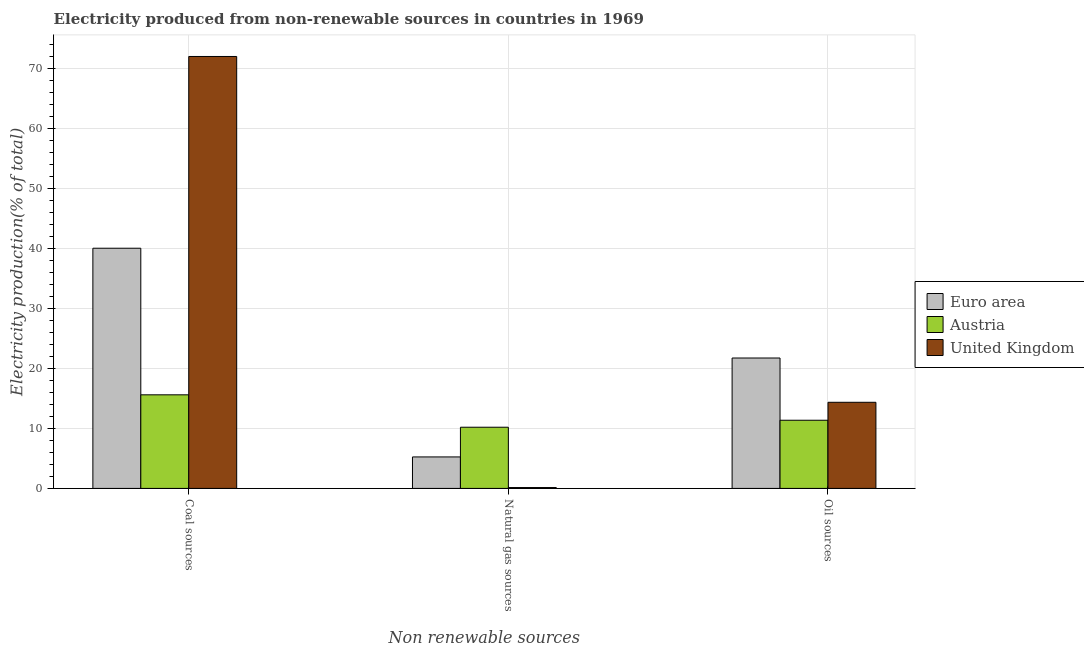How many different coloured bars are there?
Provide a succinct answer. 3. Are the number of bars on each tick of the X-axis equal?
Offer a terse response. Yes. What is the label of the 2nd group of bars from the left?
Ensure brevity in your answer.  Natural gas sources. What is the percentage of electricity produced by oil sources in Euro area?
Keep it short and to the point. 21.72. Across all countries, what is the maximum percentage of electricity produced by oil sources?
Provide a short and direct response. 21.72. Across all countries, what is the minimum percentage of electricity produced by oil sources?
Provide a succinct answer. 11.35. What is the total percentage of electricity produced by natural gas in the graph?
Your answer should be compact. 15.58. What is the difference between the percentage of electricity produced by natural gas in Euro area and that in United Kingdom?
Your response must be concise. 5.1. What is the difference between the percentage of electricity produced by natural gas in Euro area and the percentage of electricity produced by oil sources in United Kingdom?
Your answer should be compact. -9.1. What is the average percentage of electricity produced by coal per country?
Offer a very short reply. 42.5. What is the difference between the percentage of electricity produced by natural gas and percentage of electricity produced by oil sources in Austria?
Your answer should be compact. -1.16. What is the ratio of the percentage of electricity produced by oil sources in Euro area to that in Austria?
Keep it short and to the point. 1.91. Is the percentage of electricity produced by natural gas in United Kingdom less than that in Austria?
Make the answer very short. Yes. What is the difference between the highest and the second highest percentage of electricity produced by oil sources?
Your answer should be very brief. 7.37. What is the difference between the highest and the lowest percentage of electricity produced by natural gas?
Keep it short and to the point. 10.04. What does the 1st bar from the right in Natural gas sources represents?
Provide a succinct answer. United Kingdom. Is it the case that in every country, the sum of the percentage of electricity produced by coal and percentage of electricity produced by natural gas is greater than the percentage of electricity produced by oil sources?
Offer a terse response. Yes. How many bars are there?
Offer a terse response. 9. Are all the bars in the graph horizontal?
Give a very brief answer. No. What is the difference between two consecutive major ticks on the Y-axis?
Provide a short and direct response. 10. Are the values on the major ticks of Y-axis written in scientific E-notation?
Your response must be concise. No. Where does the legend appear in the graph?
Ensure brevity in your answer.  Center right. How many legend labels are there?
Provide a short and direct response. 3. How are the legend labels stacked?
Offer a very short reply. Vertical. What is the title of the graph?
Offer a very short reply. Electricity produced from non-renewable sources in countries in 1969. What is the label or title of the X-axis?
Provide a succinct answer. Non renewable sources. What is the Electricity production(% of total) of Euro area in Coal sources?
Keep it short and to the point. 39.99. What is the Electricity production(% of total) of Austria in Coal sources?
Ensure brevity in your answer.  15.59. What is the Electricity production(% of total) in United Kingdom in Coal sources?
Provide a short and direct response. 71.92. What is the Electricity production(% of total) in Euro area in Natural gas sources?
Provide a short and direct response. 5.24. What is the Electricity production(% of total) in Austria in Natural gas sources?
Provide a succinct answer. 10.19. What is the Electricity production(% of total) of United Kingdom in Natural gas sources?
Your answer should be very brief. 0.14. What is the Electricity production(% of total) in Euro area in Oil sources?
Your response must be concise. 21.72. What is the Electricity production(% of total) of Austria in Oil sources?
Provide a short and direct response. 11.35. What is the Electricity production(% of total) in United Kingdom in Oil sources?
Offer a very short reply. 14.34. Across all Non renewable sources, what is the maximum Electricity production(% of total) in Euro area?
Make the answer very short. 39.99. Across all Non renewable sources, what is the maximum Electricity production(% of total) in Austria?
Provide a succinct answer. 15.59. Across all Non renewable sources, what is the maximum Electricity production(% of total) in United Kingdom?
Provide a short and direct response. 71.92. Across all Non renewable sources, what is the minimum Electricity production(% of total) in Euro area?
Provide a short and direct response. 5.24. Across all Non renewable sources, what is the minimum Electricity production(% of total) of Austria?
Offer a terse response. 10.19. Across all Non renewable sources, what is the minimum Electricity production(% of total) of United Kingdom?
Your answer should be compact. 0.14. What is the total Electricity production(% of total) in Euro area in the graph?
Your answer should be very brief. 66.95. What is the total Electricity production(% of total) in Austria in the graph?
Your response must be concise. 37.13. What is the total Electricity production(% of total) in United Kingdom in the graph?
Your response must be concise. 86.41. What is the difference between the Electricity production(% of total) in Euro area in Coal sources and that in Natural gas sources?
Your answer should be very brief. 34.75. What is the difference between the Electricity production(% of total) in Austria in Coal sources and that in Natural gas sources?
Your answer should be very brief. 5.4. What is the difference between the Electricity production(% of total) in United Kingdom in Coal sources and that in Natural gas sources?
Your answer should be very brief. 71.78. What is the difference between the Electricity production(% of total) of Euro area in Coal sources and that in Oil sources?
Your answer should be very brief. 18.28. What is the difference between the Electricity production(% of total) of Austria in Coal sources and that in Oil sources?
Make the answer very short. 4.23. What is the difference between the Electricity production(% of total) in United Kingdom in Coal sources and that in Oil sources?
Provide a short and direct response. 57.58. What is the difference between the Electricity production(% of total) of Euro area in Natural gas sources and that in Oil sources?
Your answer should be very brief. -16.47. What is the difference between the Electricity production(% of total) in Austria in Natural gas sources and that in Oil sources?
Offer a terse response. -1.16. What is the difference between the Electricity production(% of total) in United Kingdom in Natural gas sources and that in Oil sources?
Your response must be concise. -14.2. What is the difference between the Electricity production(% of total) of Euro area in Coal sources and the Electricity production(% of total) of Austria in Natural gas sources?
Give a very brief answer. 29.81. What is the difference between the Electricity production(% of total) of Euro area in Coal sources and the Electricity production(% of total) of United Kingdom in Natural gas sources?
Offer a terse response. 39.85. What is the difference between the Electricity production(% of total) of Austria in Coal sources and the Electricity production(% of total) of United Kingdom in Natural gas sources?
Provide a short and direct response. 15.44. What is the difference between the Electricity production(% of total) of Euro area in Coal sources and the Electricity production(% of total) of Austria in Oil sources?
Make the answer very short. 28.64. What is the difference between the Electricity production(% of total) of Euro area in Coal sources and the Electricity production(% of total) of United Kingdom in Oil sources?
Keep it short and to the point. 25.65. What is the difference between the Electricity production(% of total) of Austria in Coal sources and the Electricity production(% of total) of United Kingdom in Oil sources?
Provide a short and direct response. 1.24. What is the difference between the Electricity production(% of total) of Euro area in Natural gas sources and the Electricity production(% of total) of Austria in Oil sources?
Provide a succinct answer. -6.11. What is the difference between the Electricity production(% of total) of Euro area in Natural gas sources and the Electricity production(% of total) of United Kingdom in Oil sources?
Give a very brief answer. -9.1. What is the difference between the Electricity production(% of total) in Austria in Natural gas sources and the Electricity production(% of total) in United Kingdom in Oil sources?
Offer a terse response. -4.15. What is the average Electricity production(% of total) in Euro area per Non renewable sources?
Provide a short and direct response. 22.32. What is the average Electricity production(% of total) of Austria per Non renewable sources?
Your response must be concise. 12.38. What is the average Electricity production(% of total) of United Kingdom per Non renewable sources?
Give a very brief answer. 28.8. What is the difference between the Electricity production(% of total) in Euro area and Electricity production(% of total) in Austria in Coal sources?
Offer a terse response. 24.41. What is the difference between the Electricity production(% of total) of Euro area and Electricity production(% of total) of United Kingdom in Coal sources?
Your answer should be very brief. -31.93. What is the difference between the Electricity production(% of total) of Austria and Electricity production(% of total) of United Kingdom in Coal sources?
Keep it short and to the point. -56.34. What is the difference between the Electricity production(% of total) of Euro area and Electricity production(% of total) of Austria in Natural gas sources?
Your response must be concise. -4.94. What is the difference between the Electricity production(% of total) in Euro area and Electricity production(% of total) in United Kingdom in Natural gas sources?
Ensure brevity in your answer.  5.1. What is the difference between the Electricity production(% of total) of Austria and Electricity production(% of total) of United Kingdom in Natural gas sources?
Keep it short and to the point. 10.04. What is the difference between the Electricity production(% of total) of Euro area and Electricity production(% of total) of Austria in Oil sources?
Provide a succinct answer. 10.36. What is the difference between the Electricity production(% of total) in Euro area and Electricity production(% of total) in United Kingdom in Oil sources?
Make the answer very short. 7.37. What is the difference between the Electricity production(% of total) of Austria and Electricity production(% of total) of United Kingdom in Oil sources?
Your response must be concise. -2.99. What is the ratio of the Electricity production(% of total) in Euro area in Coal sources to that in Natural gas sources?
Give a very brief answer. 7.63. What is the ratio of the Electricity production(% of total) in Austria in Coal sources to that in Natural gas sources?
Offer a very short reply. 1.53. What is the ratio of the Electricity production(% of total) of United Kingdom in Coal sources to that in Natural gas sources?
Make the answer very short. 503.26. What is the ratio of the Electricity production(% of total) of Euro area in Coal sources to that in Oil sources?
Ensure brevity in your answer.  1.84. What is the ratio of the Electricity production(% of total) in Austria in Coal sources to that in Oil sources?
Your response must be concise. 1.37. What is the ratio of the Electricity production(% of total) in United Kingdom in Coal sources to that in Oil sources?
Offer a very short reply. 5.01. What is the ratio of the Electricity production(% of total) of Euro area in Natural gas sources to that in Oil sources?
Provide a succinct answer. 0.24. What is the ratio of the Electricity production(% of total) in Austria in Natural gas sources to that in Oil sources?
Provide a succinct answer. 0.9. What is the ratio of the Electricity production(% of total) in United Kingdom in Natural gas sources to that in Oil sources?
Keep it short and to the point. 0.01. What is the difference between the highest and the second highest Electricity production(% of total) in Euro area?
Your answer should be very brief. 18.28. What is the difference between the highest and the second highest Electricity production(% of total) of Austria?
Offer a terse response. 4.23. What is the difference between the highest and the second highest Electricity production(% of total) of United Kingdom?
Provide a short and direct response. 57.58. What is the difference between the highest and the lowest Electricity production(% of total) of Euro area?
Your response must be concise. 34.75. What is the difference between the highest and the lowest Electricity production(% of total) of Austria?
Offer a terse response. 5.4. What is the difference between the highest and the lowest Electricity production(% of total) in United Kingdom?
Make the answer very short. 71.78. 